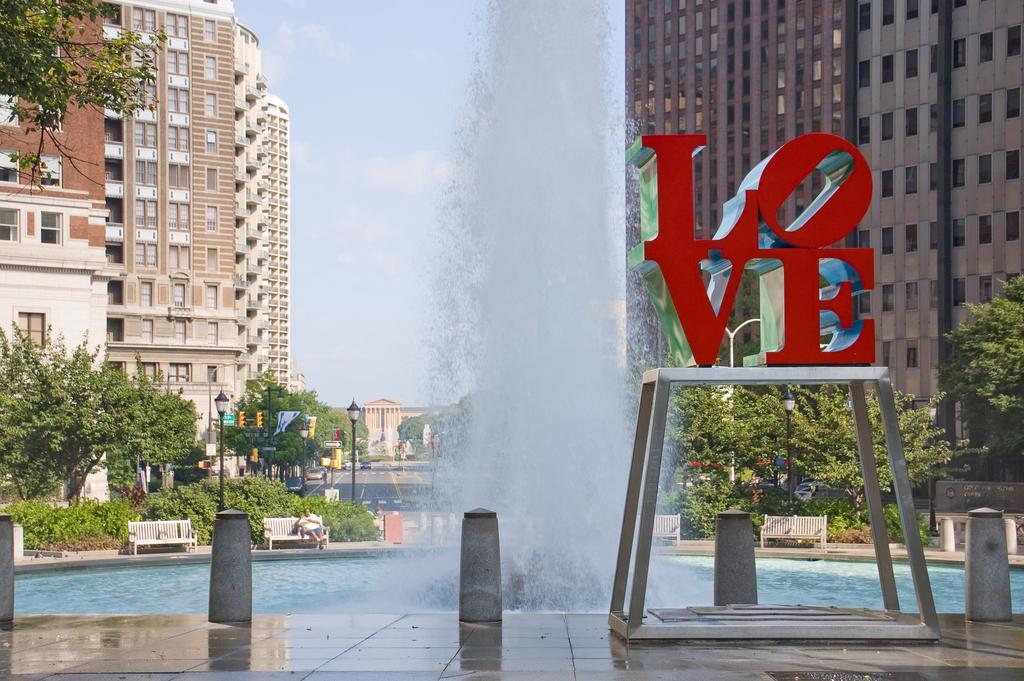Could you give a brief overview of what you see in this image? This image is clicked near the pools. In the front, there is a pool in which there is a fountain. To the left and right, there are big buildings along with trees and plants. At the bottom, there is floor. To the top, there is sky. 